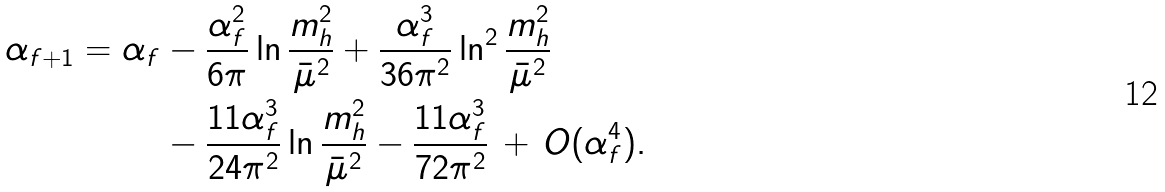<formula> <loc_0><loc_0><loc_500><loc_500>\alpha _ { f + 1 } = \alpha _ { f } & - \frac { \alpha _ { f } ^ { 2 } } { 6 \pi } \ln \frac { m _ { h } ^ { 2 } } { \bar { \mu } ^ { 2 } } + \frac { \alpha _ { f } ^ { 3 } } { 3 6 \pi ^ { 2 } } \ln ^ { 2 } \frac { m _ { h } ^ { 2 } } { \bar { \mu } ^ { 2 } } \\ & - \frac { 1 1 \alpha _ { f } ^ { 3 } } { 2 4 \pi ^ { 2 } } \ln \frac { m _ { h } ^ { 2 } } { \bar { \mu } ^ { 2 } } - \frac { 1 1 \alpha _ { f } ^ { 3 } } { 7 2 \pi ^ { 2 } } \, + \, O ( \alpha _ { f } ^ { 4 } ) .</formula> 